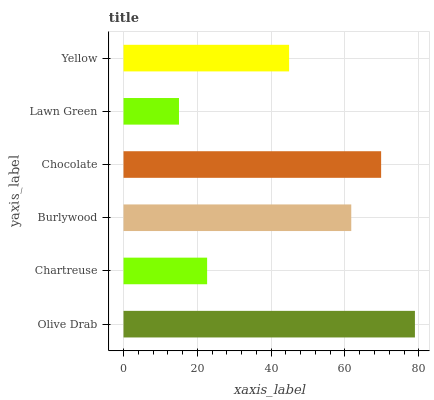Is Lawn Green the minimum?
Answer yes or no. Yes. Is Olive Drab the maximum?
Answer yes or no. Yes. Is Chartreuse the minimum?
Answer yes or no. No. Is Chartreuse the maximum?
Answer yes or no. No. Is Olive Drab greater than Chartreuse?
Answer yes or no. Yes. Is Chartreuse less than Olive Drab?
Answer yes or no. Yes. Is Chartreuse greater than Olive Drab?
Answer yes or no. No. Is Olive Drab less than Chartreuse?
Answer yes or no. No. Is Burlywood the high median?
Answer yes or no. Yes. Is Yellow the low median?
Answer yes or no. Yes. Is Lawn Green the high median?
Answer yes or no. No. Is Olive Drab the low median?
Answer yes or no. No. 